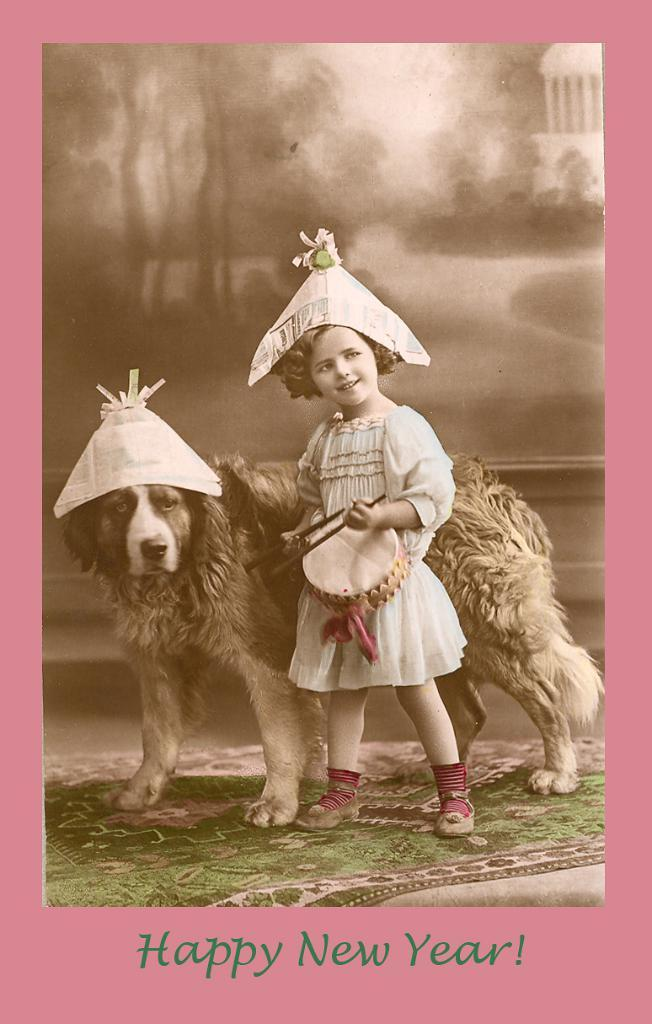What is the main subject of the card in the image? The card contains a picture of a dog and a girl standing on a carpet. Can you describe the picture on the card? The picture on the card features a dog and a girl standing on a carpet. Is there any text on the card? Yes, there is text at the bottom of the card. How much money is the dog holding in the image? There is no money present in the image; the card features a picture of a dog and a girl standing on a carpet, along with text at the bottom. 